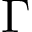<formula> <loc_0><loc_0><loc_500><loc_500>\Gamma</formula> 